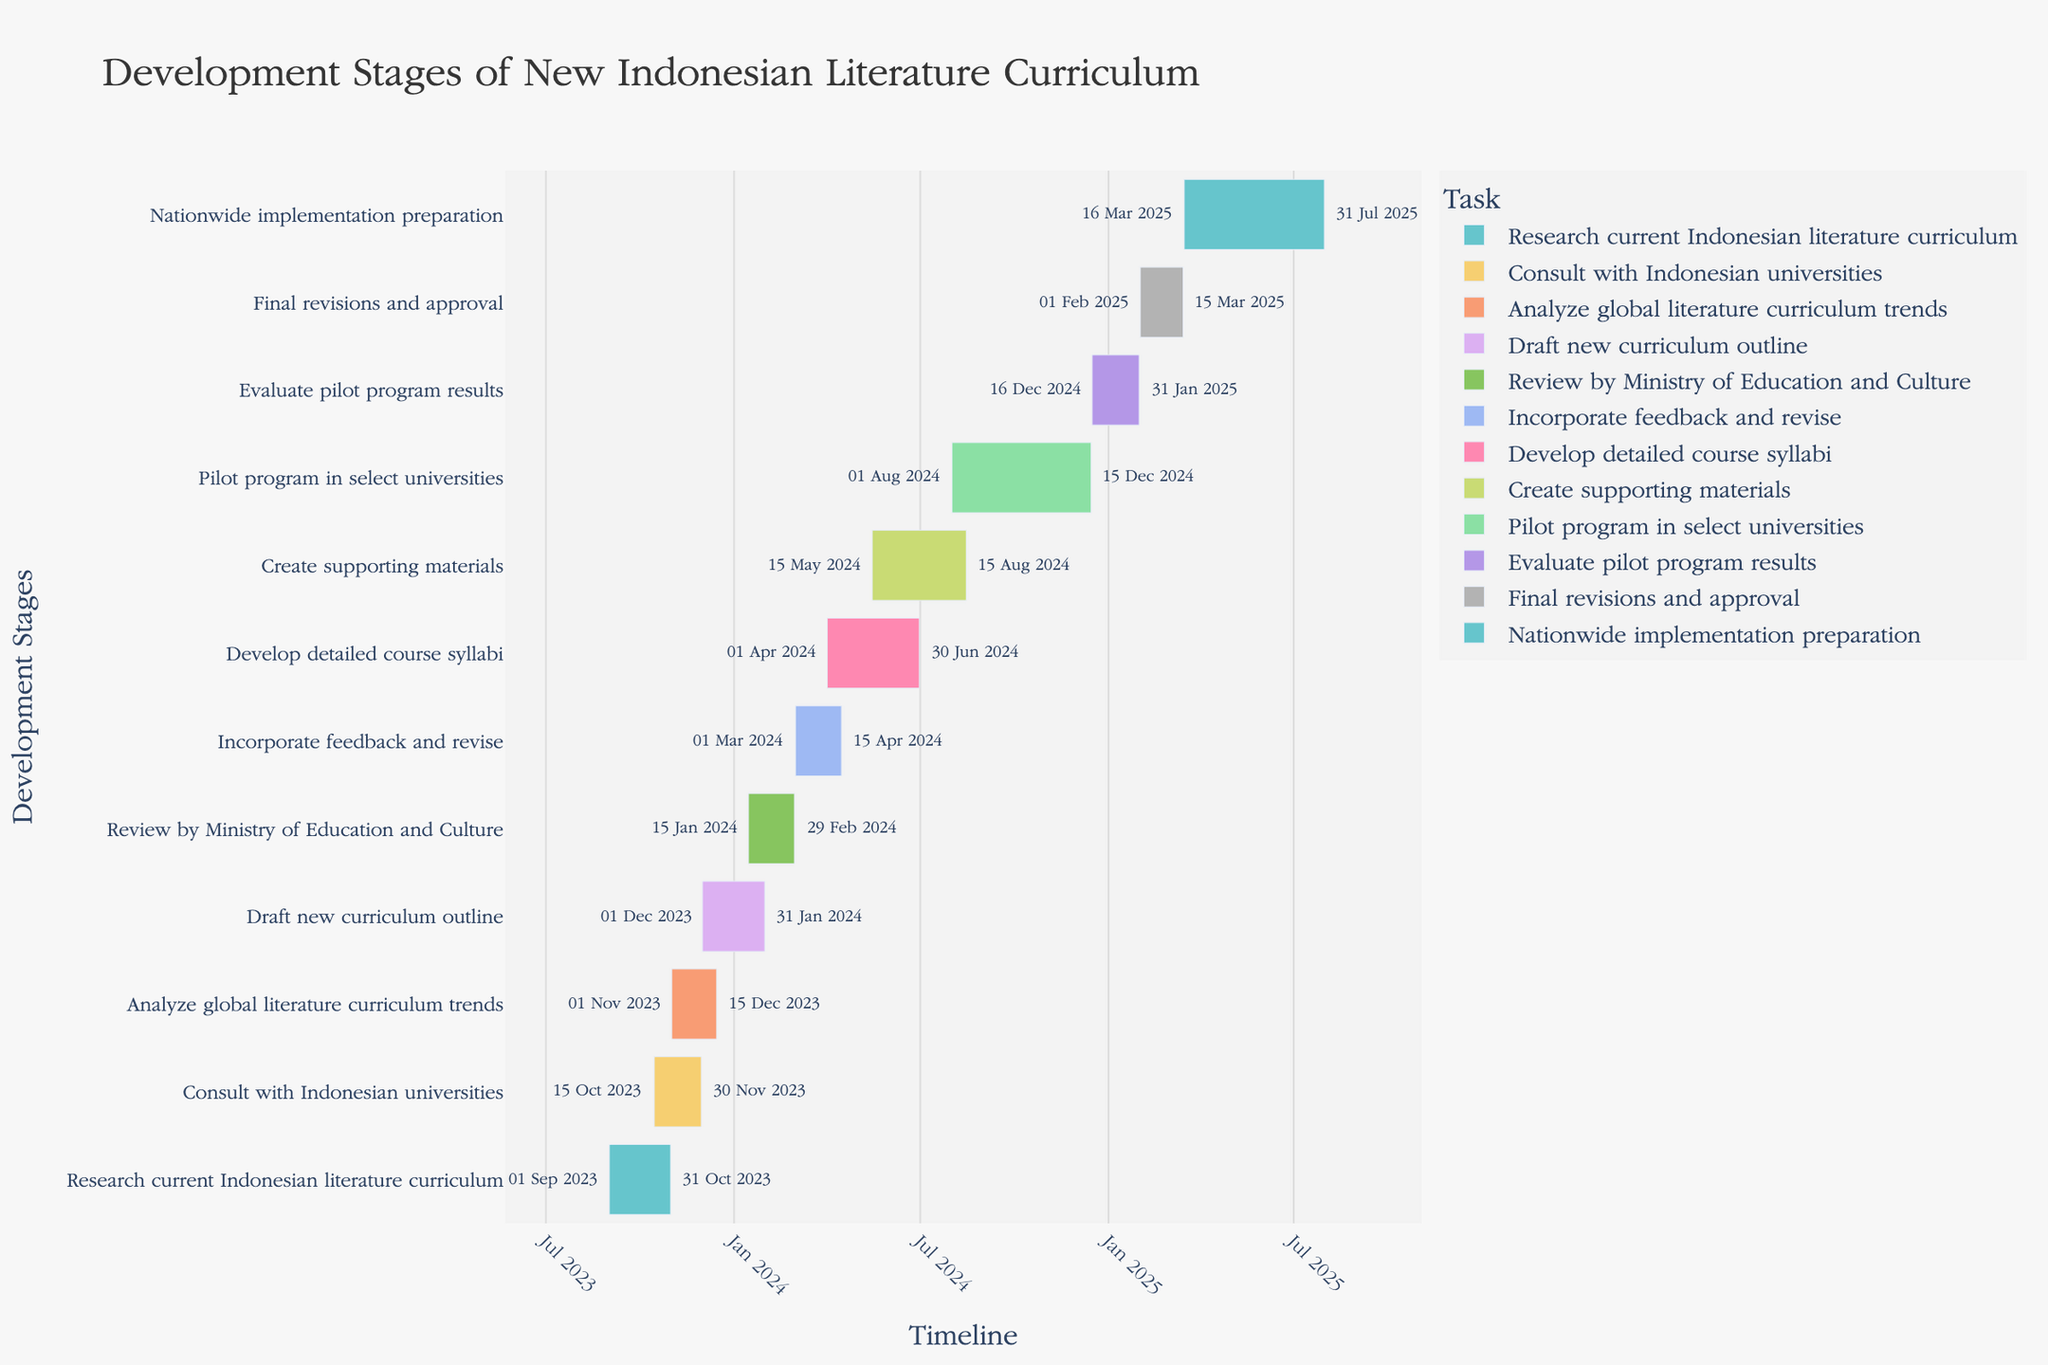Which task has the longest duration? By examining the duration of each task listed in the Gantt Chart, 'Nationwide implementation preparation' has the longest duration of 138 days.
Answer: Nationwide implementation preparation What is the total duration for 'Draft new curriculum outline' and 'Review by Ministry of Education and Culture'? To find the total duration, sum the durations of 'Draft new curriculum outline' (62 days) and 'Review by Ministry of Education and Culture' (45 days), which results in 107 days.
Answer: 107 days When does the 'Analyze global literature curriculum trends' task start and end? According to the Gantt Chart, 'Analyze global literature curriculum trends' starts on November 1, 2023, and ends on December 15, 2023.
Answer: November 1, 2023 - December 15, 2023 Which tasks are overlapping and what are their overlapping dates? By checking the timeline for overlapping intervals:
1. 'Consult with Indonesian universities' (Oct 15, 2023 - Nov 30, 2023) overlaps with 'Research current Indonesian literature curriculum' (Sep 1, 2023 - Oct 31, 2023).
2. 'Analyze global literature curriculum trends' (Nov 1, 2023 - Dec 15, 2023) overlaps with 'Consult with Indonesian universities' (Oct 15, 2023 - Nov 30, 2023).
3. 'Develop detailed course syllabi' (Apr 1, 2024 - Jun 30, 2024) overlaps with 'Incorporate feedback and revise' (Mar 1, 2024 - Apr 15, 2024).
4. 'Create supporting materials' (May 15, 2024 - Aug 15, 2024) overlaps with 'Develop detailed course syllabi' (Apr 1, 2024 - Jun 30, 2024).
5. 'Pilot program in select universities' (Aug 1, 2024 - Dec 15, 2024) overlaps with 'Create supporting materials' (May 15, 2024 - Aug 15, 2024).
Thus, tasks and their overlapping dates are identified.
Answer: Various (Consult with Indonesian universities and Research current Indonesian literature curriculum, Analyze global literature curriculum trends and Consult with Indonesian universities, Develop detailed course syllabi and Incorporate feedback and revise, Create supporting materials and Develop detailed course syllabi, Pilot program in select universities and Create supporting materials) How many tasks are scheduled to start in 2024? Tasks starting in 2024 are 'Draft new curriculum outline', 'Review by Ministry of Education and Culture', 'Incorporate feedback and revise', 'Develop detailed course syllabi', 'Create supporting materials', and 'Pilot program in select universities', summing up to 6 tasks.
Answer: 6 tasks What is the end date of the 'Final revisions and approval' task? According to the Gantt Chart, 'Final revisions and approval' ends on March 15, 2025.
Answer: March 15, 2025 Which task overlaps with 'Review by Ministry of Education and Culture'? 'Review by Ministry of Education and Culture' overlaps with 'Draft new curriculum outline' (both share the date range from January 15, 2024 to January 31, 2024).
Answer: Draft new curriculum outline What is the duration difference between 'Evaluate pilot program results' and 'Final revisions and approval'? Subtract the duration of 'Final revisions and approval' (42 days) from 'Evaluate pilot program results' (47 days), resulting in 5 days.
Answer: 5 days 